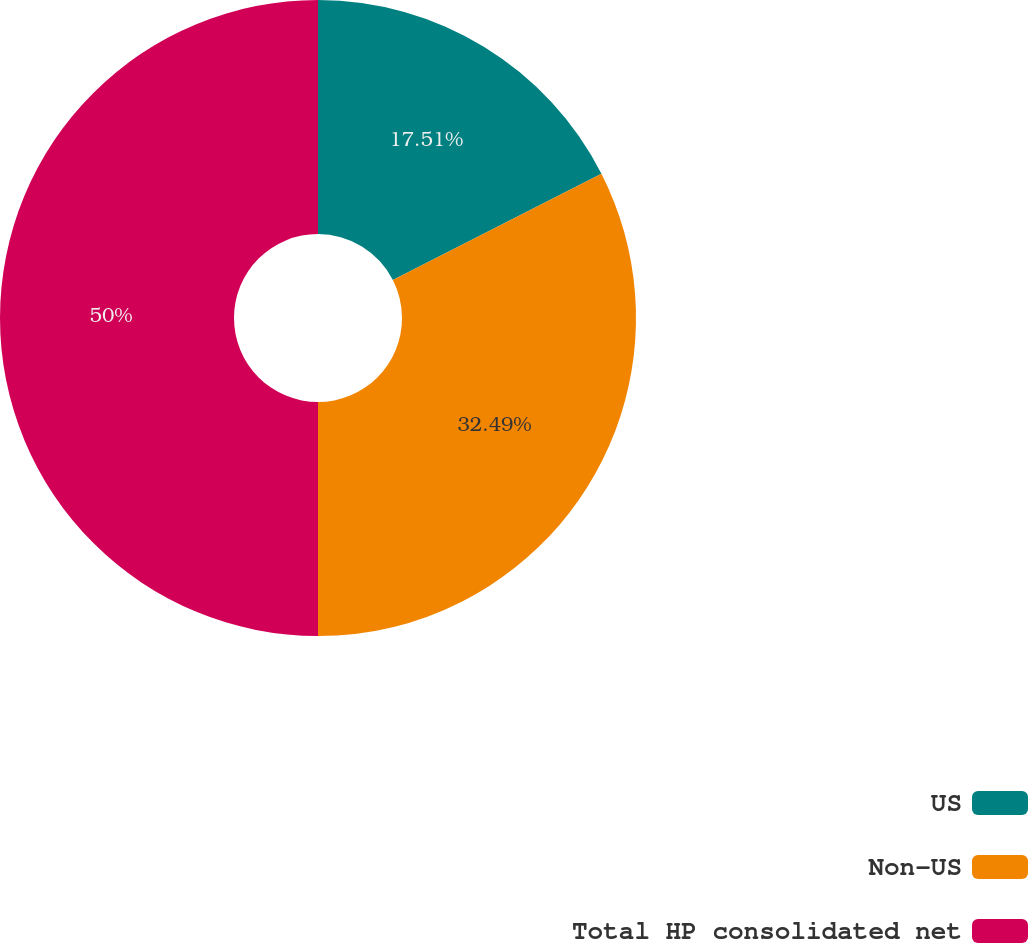Convert chart. <chart><loc_0><loc_0><loc_500><loc_500><pie_chart><fcel>US<fcel>Non-US<fcel>Total HP consolidated net<nl><fcel>17.51%<fcel>32.49%<fcel>50.0%<nl></chart> 